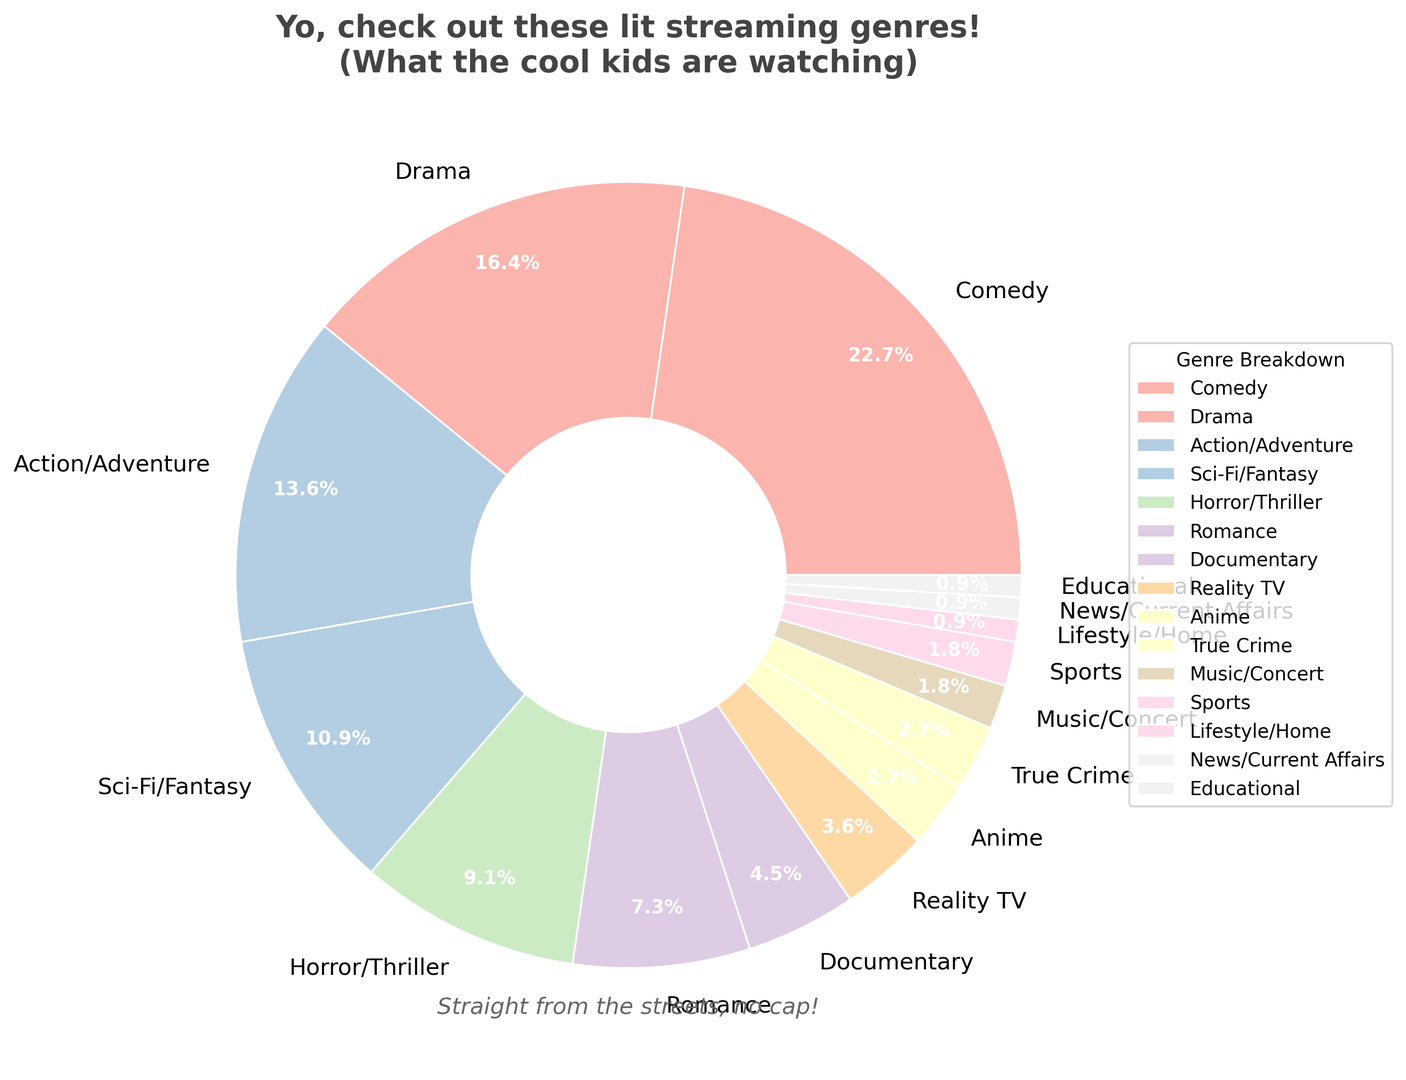what is the most popular genre according to the pie chart? The pie chart shows different genres of streaming content with their respective percentage slices. The genre with the largest slice represents the highest percentage. By looking at the chart, Comedy has the largest slice.
Answer: Comedy which genre has a higher percentage: Romance or Horror/Thriller? To find the answer, we need to compare the percentage slices for both genres. Romance is shown with 8%, while Horror/Thriller has 10%. Since 10% is greater than 8%, Horror/Thriller has a higher percentage.
Answer: Horror/Thriller what is the combined percentage of Documentary, Reality TV, and Anime? Sum the individual percentages for Documentary (5%), Reality TV (4%), and Anime (3%). The total is 5 + 4 + 3 = 12%.
Answer: 12% how much smaller is the percentage for Sci-Fi/Fantasy compared to Comedy? Subtract the percentage of Sci-Fi/Fantasy (12%) from the percentage of Comedy (25%). This gives 25 - 12 = 13%.
Answer: 13% which genres together make up exactly 5% or less of the pie chart? Look at the pie chart and identify the genres with percent slices of 5% or less. These genres are Documentary (5%), Reality TV (4%), Anime (3%), True Crime (3%), Music/Concert (2%), Sports (2%), Lifestyle/Home (1%), News/Current Affairs (1%), and Educational (1%).
Answer: Documentary, Reality TV, Anime, True Crime, Music/Concert, Sports, Lifestyle/Home, News/Current Affairs, Educational how many genres together make up more than half of the pie chart? We need to determine how many genres' percentages add up to more than 50%. Adding up the largest slices first: Comedy (25%), Drama (18%), Action/Adventure (15%). The sum is 25 + 18 + 15 = 58%, which is greater than half. So, three genres together constitute over half.
Answer: 3 does the combined percentage of Action/Adventure, Sci-Fi/Fantasy, and Horror/Thriller exceed Comedy? Add the percentages of Action/Adventure (15%), Sci-Fi/Fantasy (12%), and Horror/Thriller (10%) and compare it to Comedy (25%). The sum is 15 + 12 + 10 = 37%, which is greater than 25%.
Answer: Yes which genre has the smallest slice in the pie chart? The smallest slice corresponds to the smallest percentage. In this pie chart, Lifestyle/Home, News/Current Affairs, and Educational each have 1%, which is the smallest.
Answer: Lifestyle/Home, News/Current Affairs, Educational what is the total percentage for genres classified under 10%? Find and sum all the genres with percentages less than 10%. These include Romance (8%), Documentary (5%), Reality TV (4%), Anime (3%), True Crime (3%), Music/Concert (2%), Sports (2%), Lifestyle/Home (1%), News/Current Affairs (1%), and Educational (1%). Sum is 8+5+4+3+3+2+2+1+1+1 = 30%.
Answer: 30% out of Drama and Romance, which one is less preferred? Compare the percentages of Drama and Romance. Drama is 18%, and Romance is 8%. Since 8% is less than 18%, Romance is less preferred.
Answer: Romance 